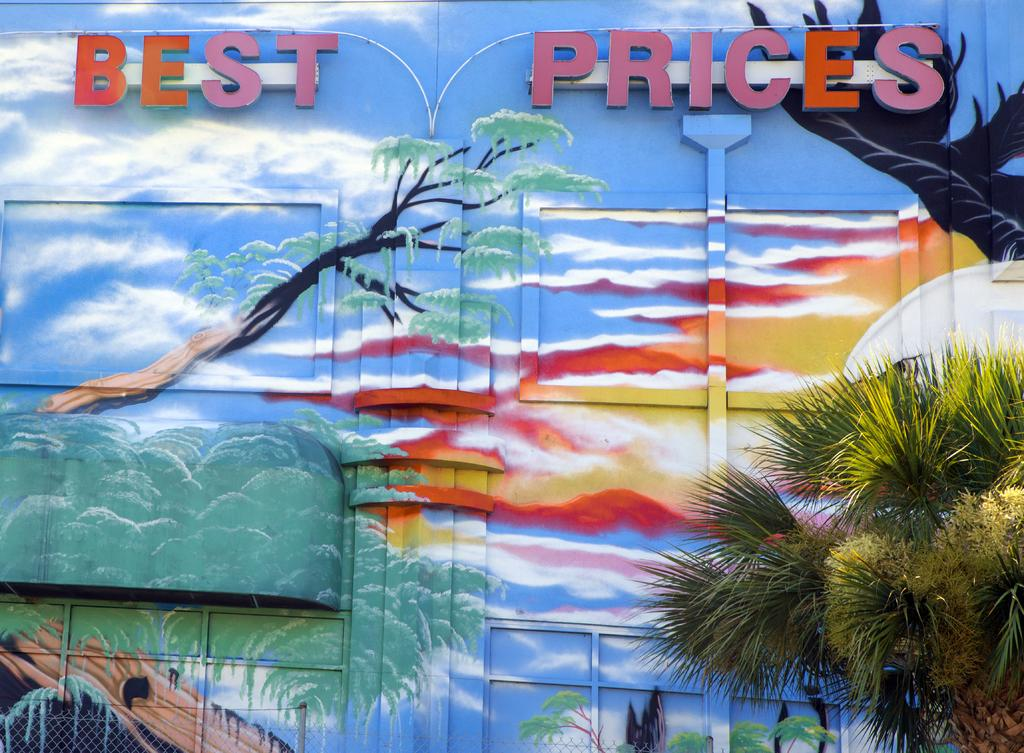What type of structure is present in the image? There is a building in the image. How can the building be identified? The building has a name board. What kind of artwork is visible in the image? There is a wall painting in the image. What type of vegetation can be seen in the image? There is a tree visible in the image. What is the purpose of the barrier at the bottom of the image? There is a fence at the bottom of the image. What brand of toothpaste is advertised on the window in the image? There is no window or toothpaste advertised in the image; it features a building with a name board, a wall painting, a tree, and a fence. 